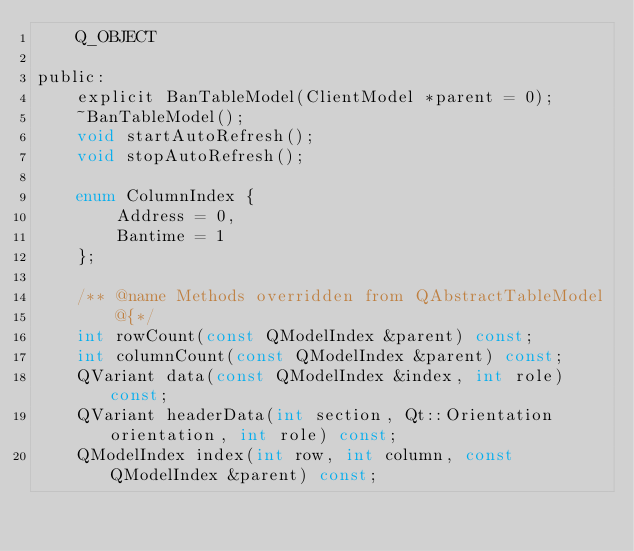Convert code to text. <code><loc_0><loc_0><loc_500><loc_500><_C_>    Q_OBJECT

public:
    explicit BanTableModel(ClientModel *parent = 0);
    ~BanTableModel();
    void startAutoRefresh();
    void stopAutoRefresh();

    enum ColumnIndex {
        Address = 0,
        Bantime = 1
    };

    /** @name Methods overridden from QAbstractTableModel
        @{*/
    int rowCount(const QModelIndex &parent) const;
    int columnCount(const QModelIndex &parent) const;
    QVariant data(const QModelIndex &index, int role) const;
    QVariant headerData(int section, Qt::Orientation orientation, int role) const;
    QModelIndex index(int row, int column, const QModelIndex &parent) const;</code> 